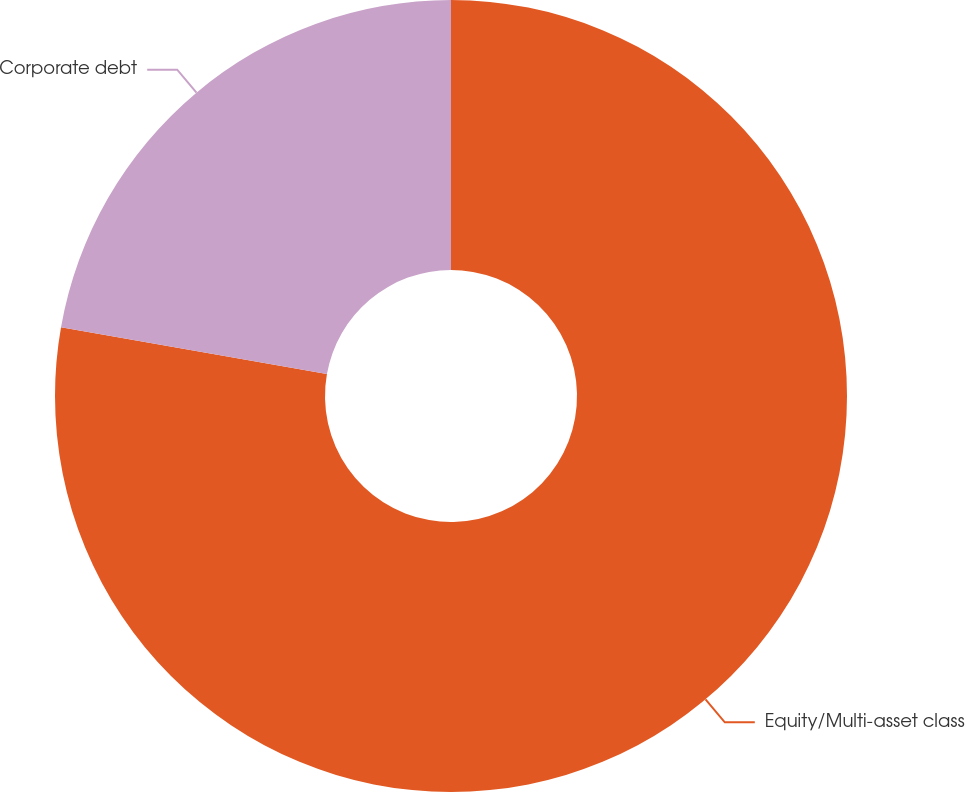Convert chart. <chart><loc_0><loc_0><loc_500><loc_500><pie_chart><fcel>Equity/Multi-asset class<fcel>Corporate debt<nl><fcel>77.78%<fcel>22.22%<nl></chart> 